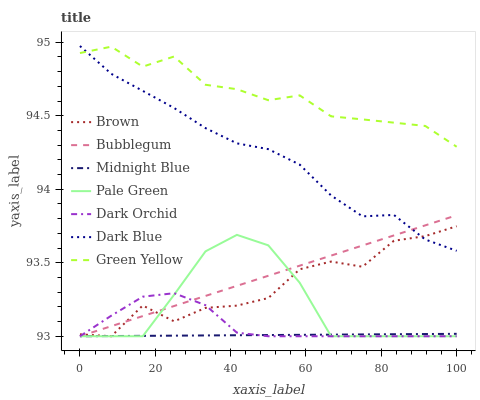Does Midnight Blue have the minimum area under the curve?
Answer yes or no. Yes. Does Green Yellow have the maximum area under the curve?
Answer yes or no. Yes. Does Dark Orchid have the minimum area under the curve?
Answer yes or no. No. Does Dark Orchid have the maximum area under the curve?
Answer yes or no. No. Is Bubblegum the smoothest?
Answer yes or no. Yes. Is Brown the roughest?
Answer yes or no. Yes. Is Midnight Blue the smoothest?
Answer yes or no. No. Is Midnight Blue the roughest?
Answer yes or no. No. Does Brown have the lowest value?
Answer yes or no. Yes. Does Dark Blue have the lowest value?
Answer yes or no. No. Does Dark Blue have the highest value?
Answer yes or no. Yes. Does Dark Orchid have the highest value?
Answer yes or no. No. Is Bubblegum less than Green Yellow?
Answer yes or no. Yes. Is Green Yellow greater than Pale Green?
Answer yes or no. Yes. Does Pale Green intersect Midnight Blue?
Answer yes or no. Yes. Is Pale Green less than Midnight Blue?
Answer yes or no. No. Is Pale Green greater than Midnight Blue?
Answer yes or no. No. Does Bubblegum intersect Green Yellow?
Answer yes or no. No. 